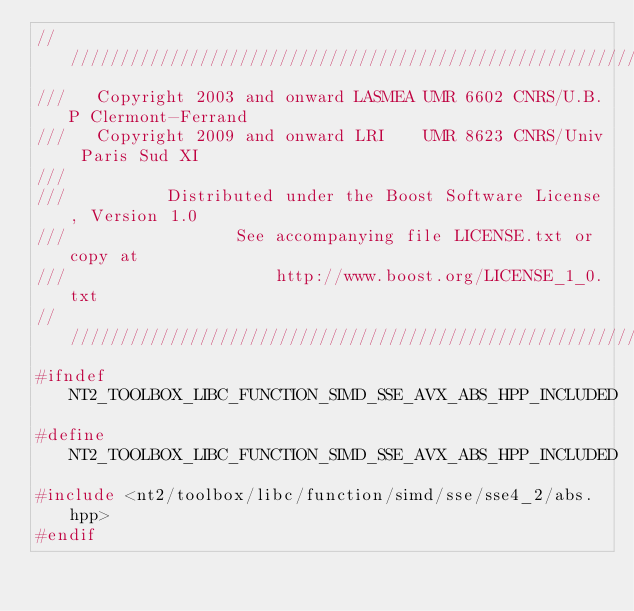<code> <loc_0><loc_0><loc_500><loc_500><_C++_>//////////////////////////////////////////////////////////////////////////////
///   Copyright 2003 and onward LASMEA UMR 6602 CNRS/U.B.P Clermont-Ferrand
///   Copyright 2009 and onward LRI    UMR 8623 CNRS/Univ Paris Sud XI
///
///          Distributed under the Boost Software License, Version 1.0
///                 See accompanying file LICENSE.txt or copy at
///                     http://www.boost.org/LICENSE_1_0.txt
//////////////////////////////////////////////////////////////////////////////
#ifndef NT2_TOOLBOX_LIBC_FUNCTION_SIMD_SSE_AVX_ABS_HPP_INCLUDED
#define NT2_TOOLBOX_LIBC_FUNCTION_SIMD_SSE_AVX_ABS_HPP_INCLUDED
#include <nt2/toolbox/libc/function/simd/sse/sse4_2/abs.hpp>
#endif
</code> 